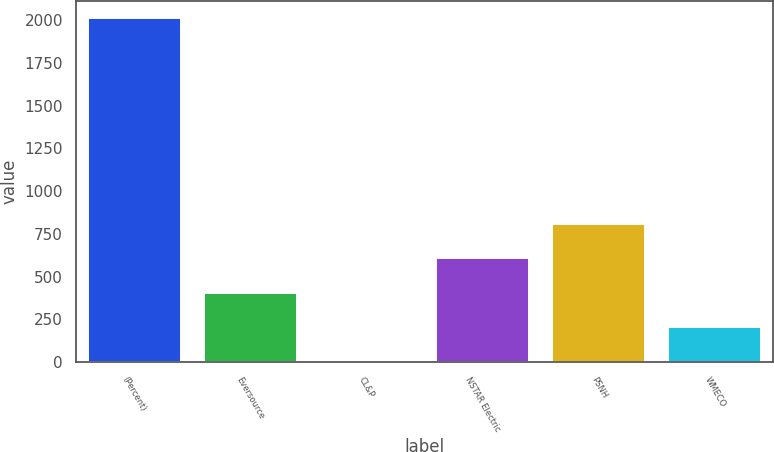Convert chart. <chart><loc_0><loc_0><loc_500><loc_500><bar_chart><fcel>(Percent)<fcel>Eversource<fcel>CL&P<fcel>NSTAR Electric<fcel>PSNH<fcel>WMECO<nl><fcel>2015<fcel>405.16<fcel>2.7<fcel>606.39<fcel>807.62<fcel>203.93<nl></chart> 